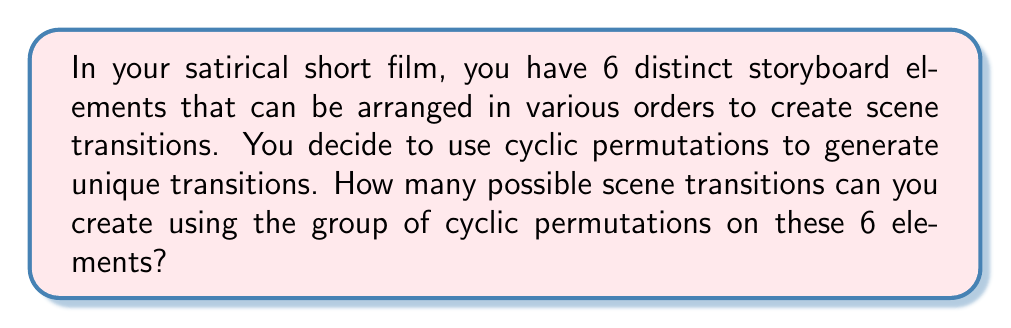Help me with this question. To solve this problem, we need to understand the properties of cyclic permutations in group theory:

1) First, recall that a cyclic permutation of $n$ elements is a permutation that moves each element to the position of the next element in a cyclic manner.

2) The group of cyclic permutations on $n$ elements is isomorphic to the cyclic group $C_n$.

3) The order of the cyclic group $C_n$ is equal to $n$.

In this case, we have 6 storyboard elements, so we're working with $C_6$.

4) The number of possible scene transitions is equal to the number of distinct elements in $C_6$.

5) Therefore, the number of possible scene transitions is equal to the order of $C_6$, which is 6.

To visualize this, consider the following cyclic permutations of the elements $(1,2,3,4,5,6)$:

$$(1,2,3,4,5,6)$$
$$(2,3,4,5,6,1)$$
$$(3,4,5,6,1,2)$$
$$(4,5,6,1,2,3)$$
$$(5,6,1,2,3,4)$$
$$(6,1,2,3,4,5)$$

Each of these represents a unique scene transition in your short film.
Answer: The number of possible scene transitions using cyclic permutations on 6 storyboard elements is $6$. 